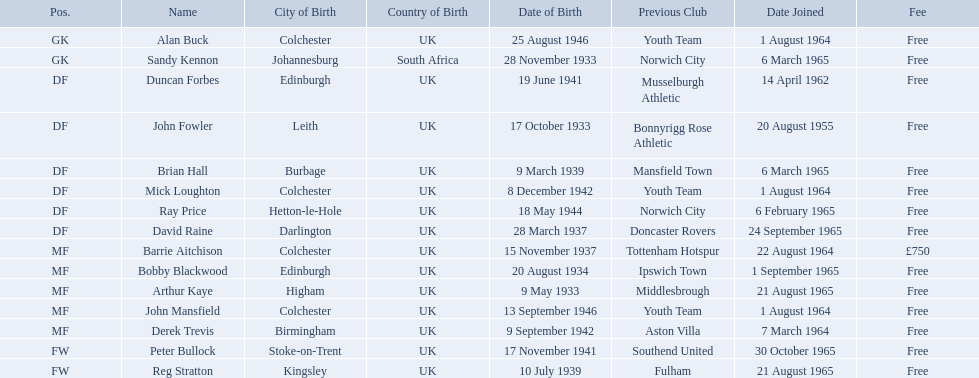Who are all the players? Alan Buck, Sandy Kennon, Duncan Forbes, John Fowler, Brian Hall, Mick Loughton, Ray Price, David Raine, Barrie Aitchison, Bobby Blackwood, Arthur Kaye, John Mansfield, Derek Trevis, Peter Bullock, Reg Stratton. What dates did the players join on? 1 August 1964, 6 March 1965, 14 April 1962, 20 August 1955, 6 March 1965, 1 August 1964, 6 February 1965, 24 September 1965, 22 August 1964, 1 September 1965, 21 August 1965, 1 August 1964, 7 March 1964, 30 October 1965, 21 August 1965. Who is the first player who joined? John Fowler. What is the date of the first person who joined? 20 August 1955. 